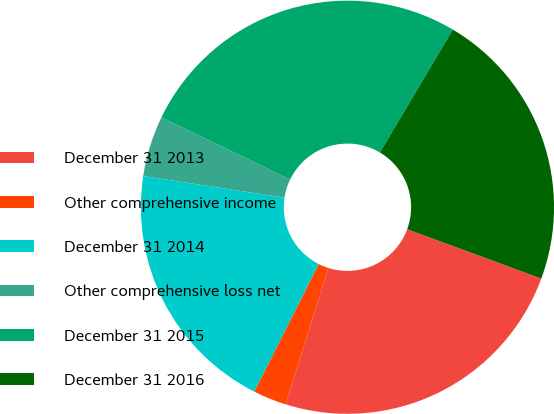<chart> <loc_0><loc_0><loc_500><loc_500><pie_chart><fcel>December 31 2013<fcel>Other comprehensive income<fcel>December 31 2014<fcel>Other comprehensive loss net<fcel>December 31 2015<fcel>December 31 2016<nl><fcel>24.23%<fcel>2.61%<fcel>19.96%<fcel>4.75%<fcel>26.36%<fcel>22.09%<nl></chart> 